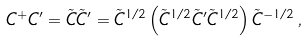Convert formula to latex. <formula><loc_0><loc_0><loc_500><loc_500>C ^ { + } C ^ { \prime } = \tilde { C } \tilde { C } ^ { \prime } = \tilde { C } ^ { 1 / 2 } \left ( \tilde { C } ^ { 1 / 2 } \tilde { C } ^ { \prime } \tilde { C } ^ { 1 / 2 } \right ) \tilde { C } ^ { - 1 / 2 } \, ,</formula> 